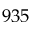Convert formula to latex. <formula><loc_0><loc_0><loc_500><loc_500>9 3 5</formula> 